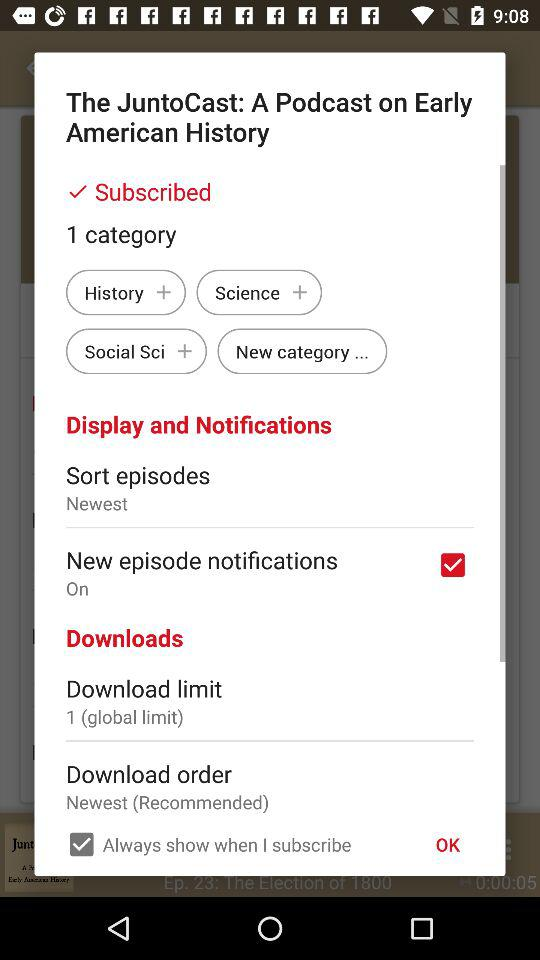How are the episodes sorted? The episodes are sorted according to "Newest". 